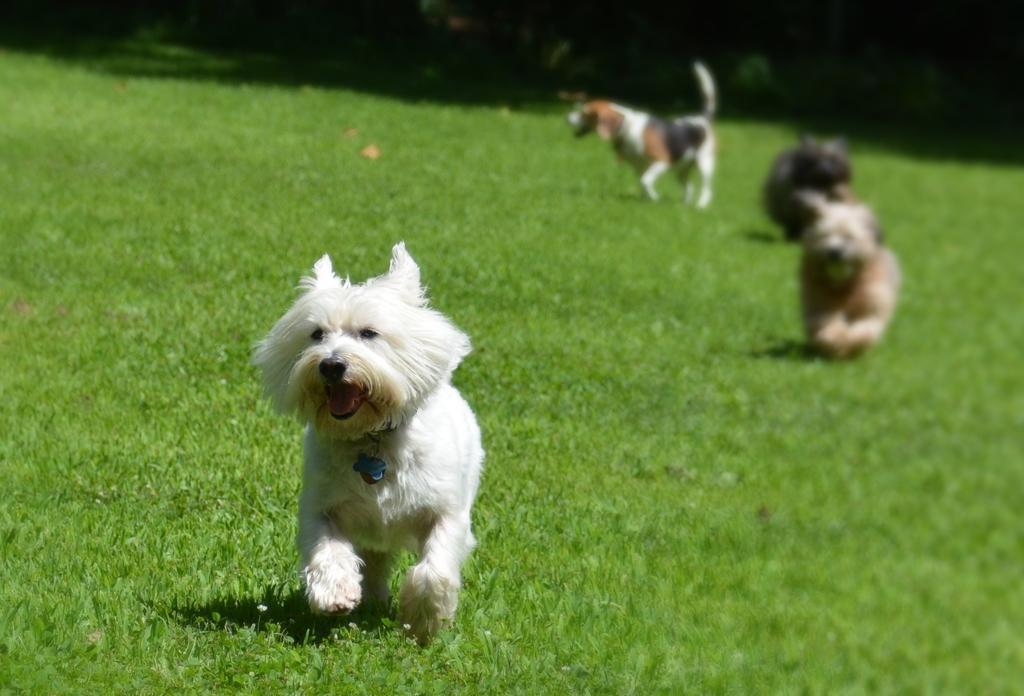Please provide a concise description of this image. This image consists of three dogs on grass and plants. This image is taken may be in a park during a day. 